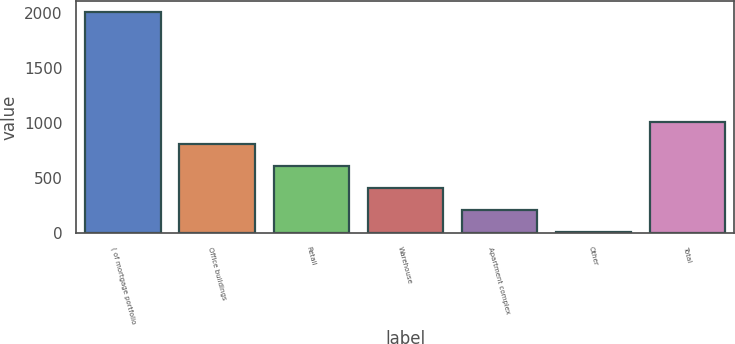Convert chart. <chart><loc_0><loc_0><loc_500><loc_500><bar_chart><fcel>( of mortgage portfolio<fcel>Office buildings<fcel>Retail<fcel>Warehouse<fcel>Apartment complex<fcel>Other<fcel>Total<nl><fcel>2009<fcel>806.84<fcel>606.48<fcel>406.12<fcel>205.76<fcel>5.4<fcel>1007.2<nl></chart> 